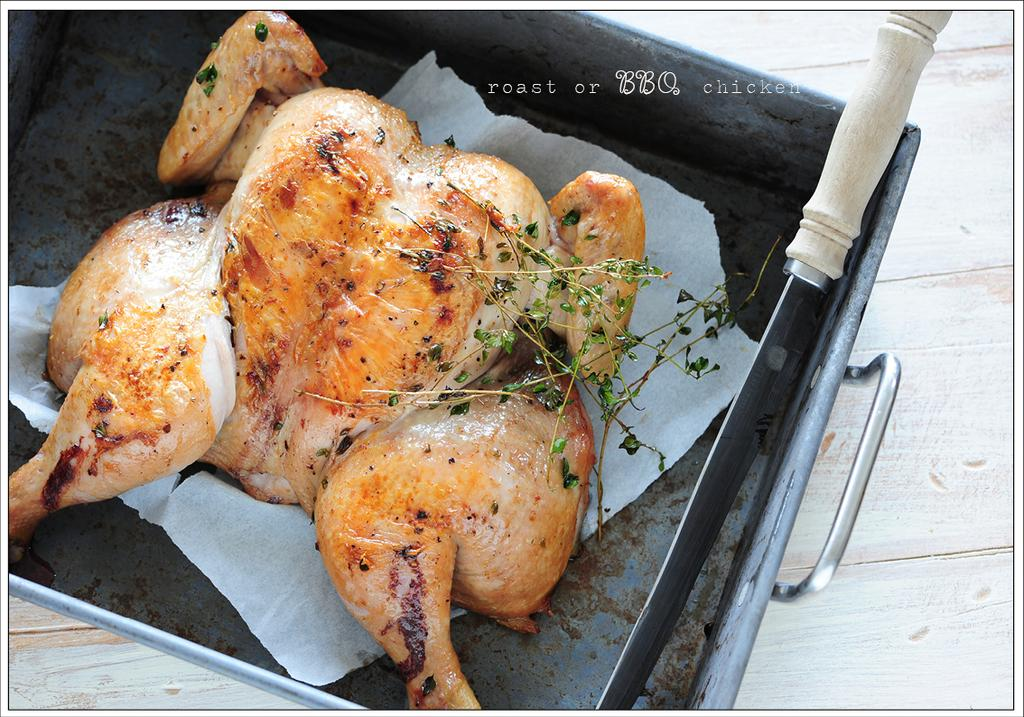What type of meat is in the tray or vessel in the image? There is chicken meat in the tray or vessel in the image. What material is the tissue paper made of in the image? The tissue paper is present in the image, but the material is not specified. What type of herb is visible in the image? Mint leaves are visible in the image. What utensil is present in the image? A knife is present in the image. What is the surface on which the objects are placed in the image? The objects are placed on a wooden table in the image. Where is the tiger positioned in the image? There is no tiger present in the image. What type of plants can be seen growing on the wooden table in the image? There are no plants visible on the wooden table in the image. 